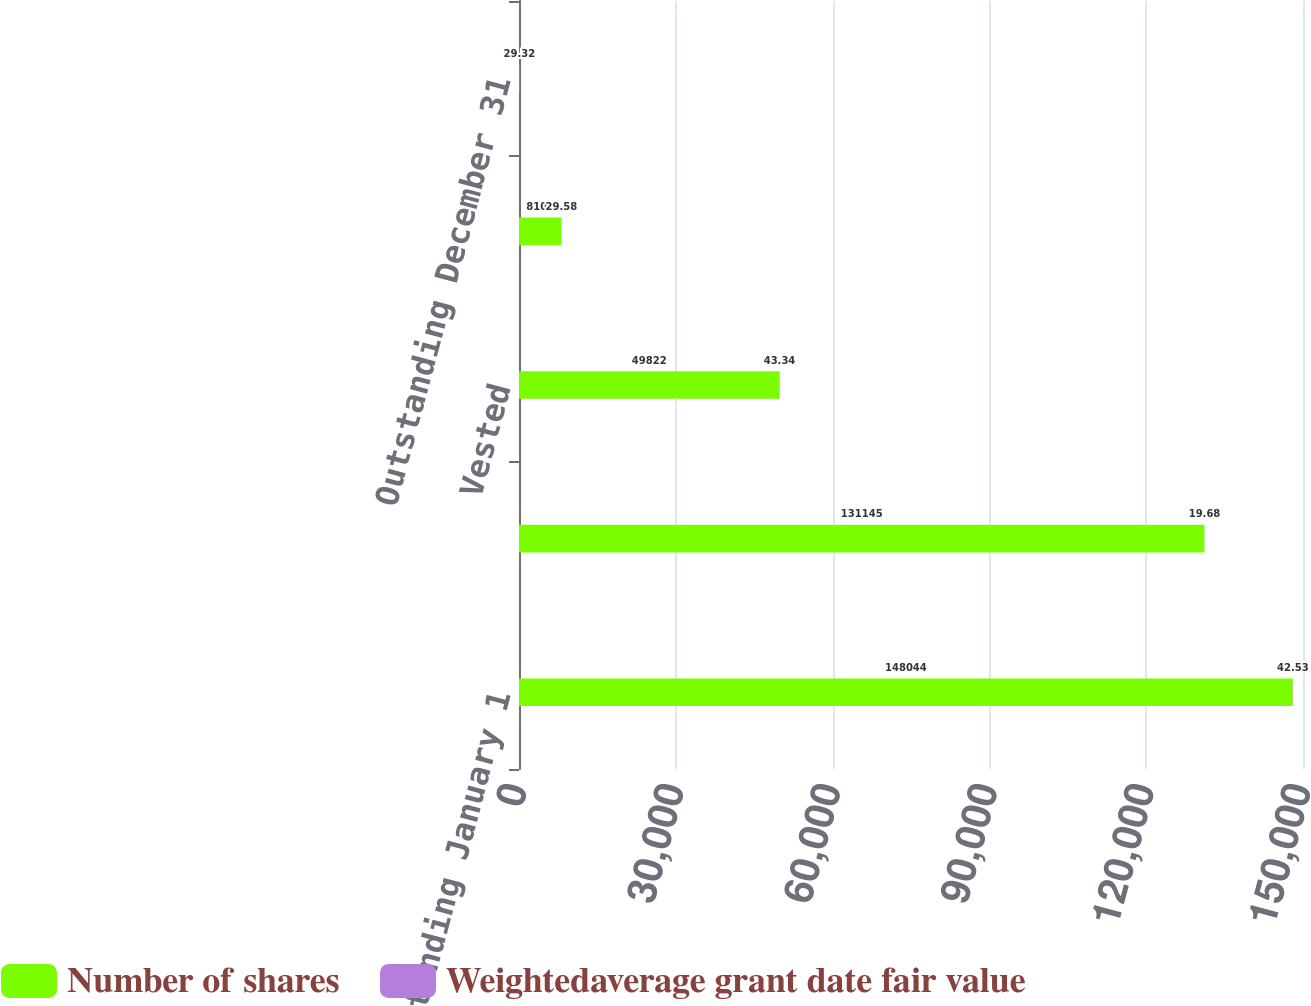<chart> <loc_0><loc_0><loc_500><loc_500><stacked_bar_chart><ecel><fcel>Outstanding January 1<fcel>Granted<fcel>Vested<fcel>Forfeited<fcel>Outstanding December 31<nl><fcel>Number of shares<fcel>148044<fcel>131145<fcel>49822<fcel>8102<fcel>43.34<nl><fcel>Weightedaverage grant date fair value<fcel>42.53<fcel>19.68<fcel>43.34<fcel>29.58<fcel>29.32<nl></chart> 